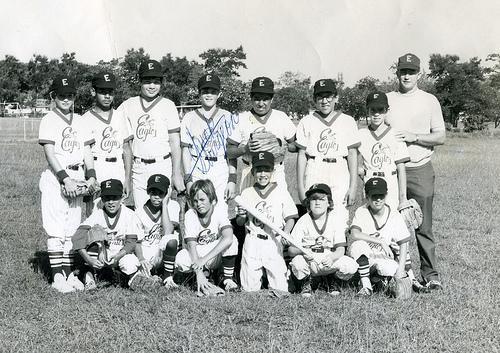How many people are there?
Give a very brief answer. 14. 